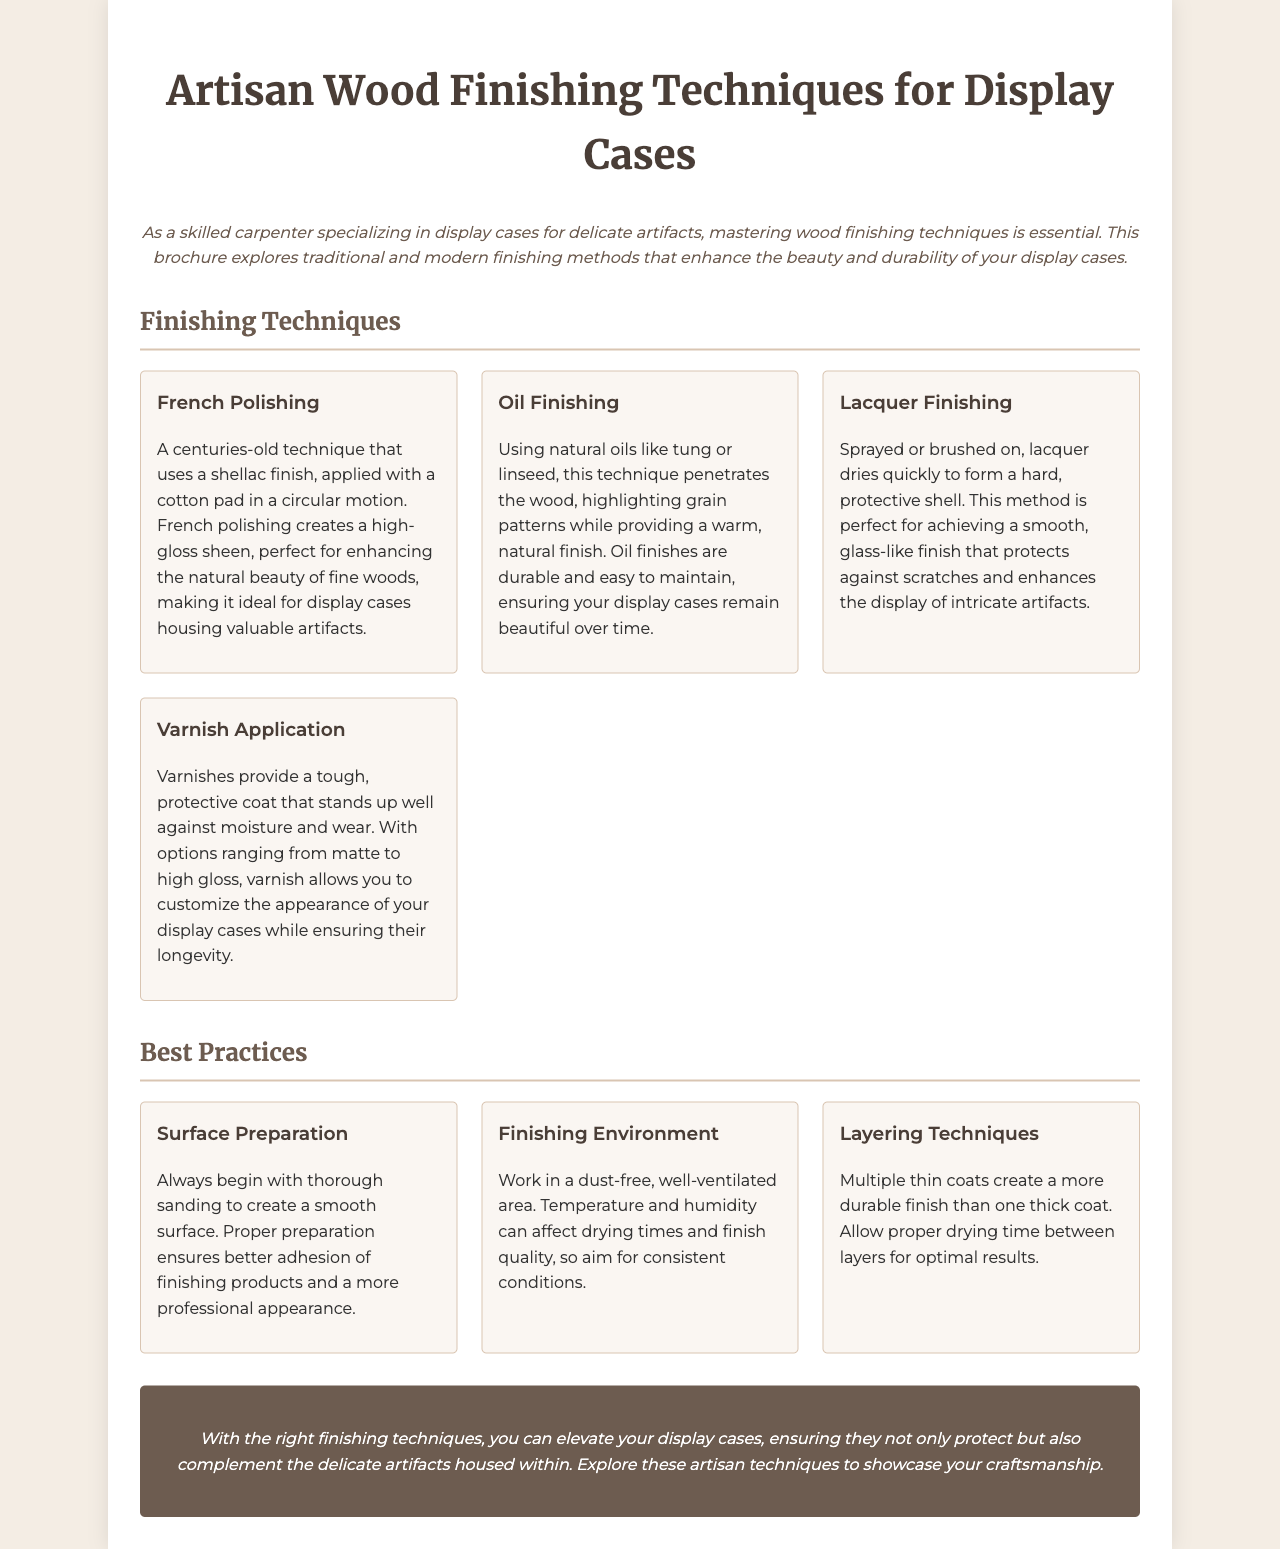What is the title of the brochure? The title is prominently displayed at the top of the document, which is "Artisan Wood Finishing Techniques for Display Cases."
Answer: Artisan Wood Finishing Techniques for Display Cases How many finishing techniques are listed? The document lists four different finishing techniques under the section about Finishing Techniques.
Answer: 4 What is the first finishing technique mentioned? The first technique is clearly labeled in the techniques section, which is "French Polishing."
Answer: French Polishing What is emphasized in the "Best Practices" section? The section outlines three key practices important for wood finishing, highlighting the importance of surface preparation, the working environment, and layering techniques.
Answer: Surface Preparation What type of environment is recommended for finishing? The suggestion is made to work in a dust-free, well-ventilated area to ensure quality results.
Answer: Dust-free, well-ventilated Why is layering techniques important? It is noted that multiple thin coats lead to a more durable finish than one thick coat, indicating the significance of proper application.
Answer: More durable finish What color scheme is used for headings in the document? The headings are designed in a dark color scheme, specifically "#4a3e37" for the primary headings.
Answer: Dark color scheme What type of finish does lacquer provide? The lacquer finishing method is described as providing a smooth, glass-like finish.
Answer: Smooth, glass-like finish What is the overall purpose of the brochure? The brochure aims to educate readers about artisan wood finishing techniques specific to display cases that enhance durability and beauty.
Answer: Educate readers about artisan wood finishing techniques 